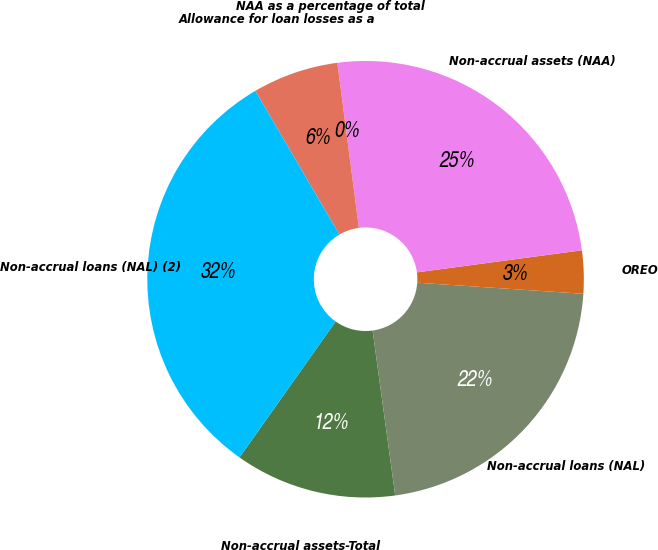Convert chart. <chart><loc_0><loc_0><loc_500><loc_500><pie_chart><fcel>Non-accrual assets-Total<fcel>Non-accrual loans (NAL)<fcel>OREO<fcel>Non-accrual assets (NAA)<fcel>NAA as a percentage of total<fcel>Allowance for loan losses as a<fcel>Non-accrual loans (NAL) (2)<nl><fcel>11.97%<fcel>21.77%<fcel>3.18%<fcel>24.95%<fcel>0.0%<fcel>6.36%<fcel>31.78%<nl></chart> 